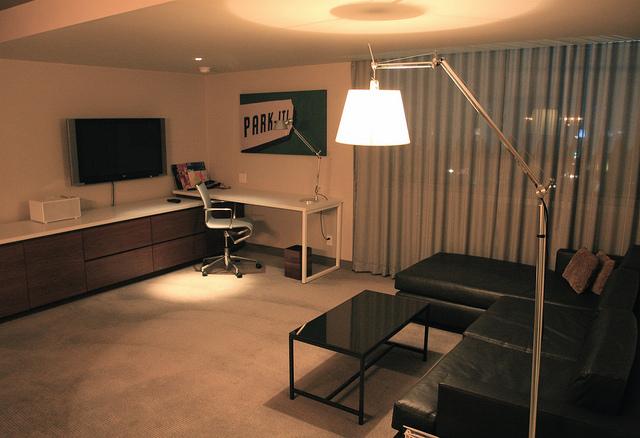What color is the chair in the room?
Short answer required. White. Where does it say "Park"?
Answer briefly. On picture. What is written on the wall?
Keep it brief. Park. Is this an office?
Keep it brief. No. 